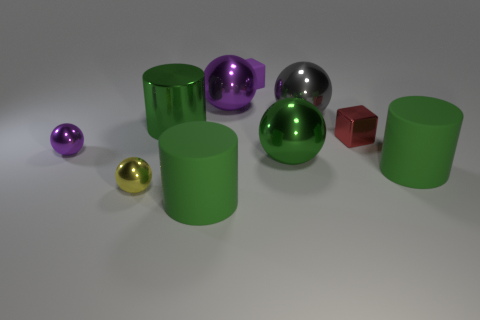How many green cylinders must be subtracted to get 1 green cylinders? 2 Subtract all purple blocks. How many blocks are left? 1 Subtract all yellow shiny balls. How many balls are left? 4 Subtract 1 spheres. How many spheres are left? 4 Add 7 large green shiny balls. How many large green shiny balls exist? 8 Subtract 0 blue spheres. How many objects are left? 10 Subtract all blocks. How many objects are left? 8 Subtract all cyan balls. Subtract all red cubes. How many balls are left? 5 Subtract all blue cubes. How many yellow balls are left? 1 Subtract all green objects. Subtract all big purple metallic things. How many objects are left? 5 